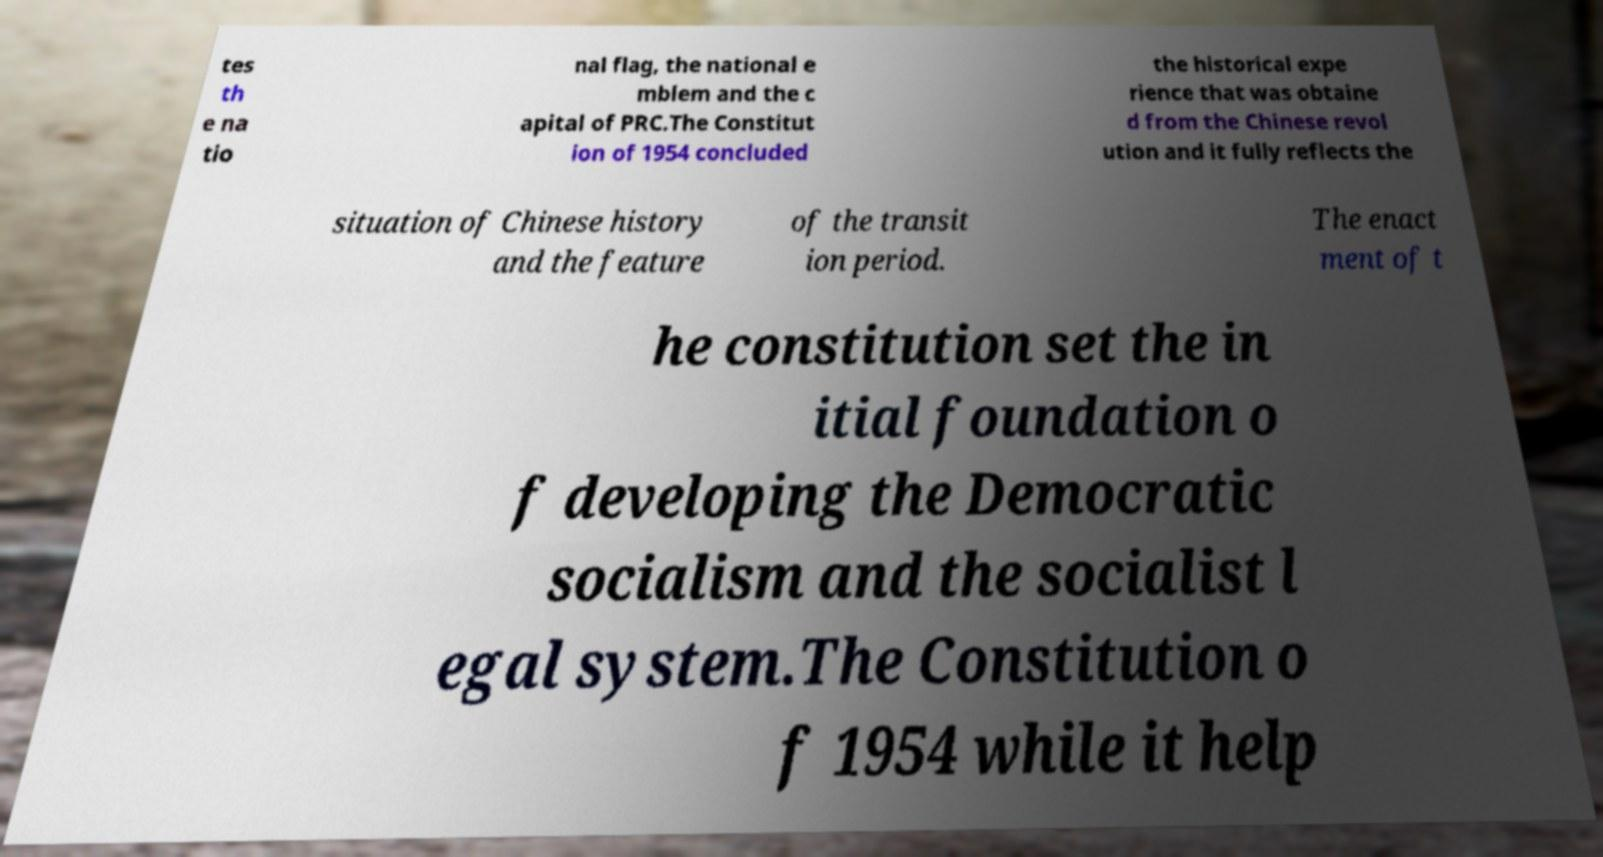There's text embedded in this image that I need extracted. Can you transcribe it verbatim? tes th e na tio nal flag, the national e mblem and the c apital of PRC.The Constitut ion of 1954 concluded the historical expe rience that was obtaine d from the Chinese revol ution and it fully reflects the situation of Chinese history and the feature of the transit ion period. The enact ment of t he constitution set the in itial foundation o f developing the Democratic socialism and the socialist l egal system.The Constitution o f 1954 while it help 